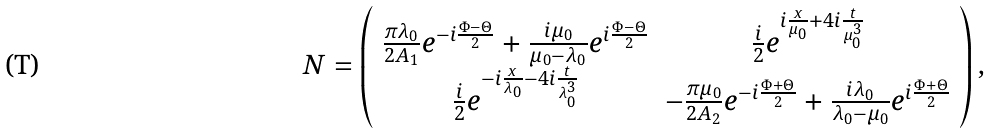<formula> <loc_0><loc_0><loc_500><loc_500>N = \left ( \begin{array} { c c } \frac { \pi \lambda _ { 0 } } { 2 A _ { 1 } } e ^ { - i \frac { \Phi - \Theta } { 2 } } + \frac { i \mu _ { 0 } } { \mu _ { 0 } - \lambda _ { 0 } } e ^ { i \frac { \Phi - \Theta } { 2 } } & \frac { i } { 2 } e ^ { i \frac { x } { \mu _ { 0 } } + 4 i \frac { t } { \mu ^ { 3 } _ { 0 } } } \\ \frac { i } { 2 } e ^ { - i \frac { x } { \lambda _ { 0 } } - 4 i \frac { t } { \lambda ^ { 3 } _ { 0 } } } & - \frac { \pi \mu _ { 0 } } { 2 A _ { 2 } } e ^ { - i \frac { \Phi + \Theta } { 2 } } + \frac { i \lambda _ { 0 } } { \lambda _ { 0 } - \mu _ { 0 } } e ^ { i \frac { \Phi + \Theta } { 2 } } \\ \end{array} \right ) ,</formula> 